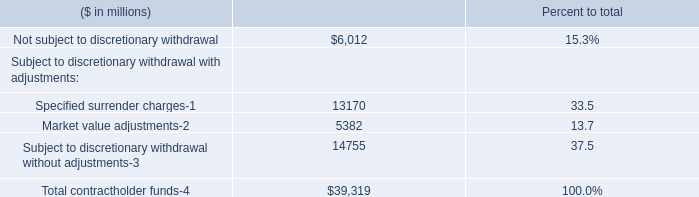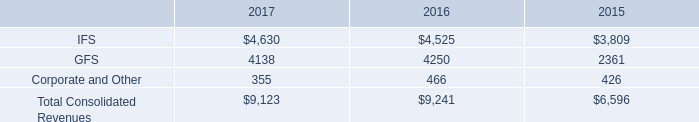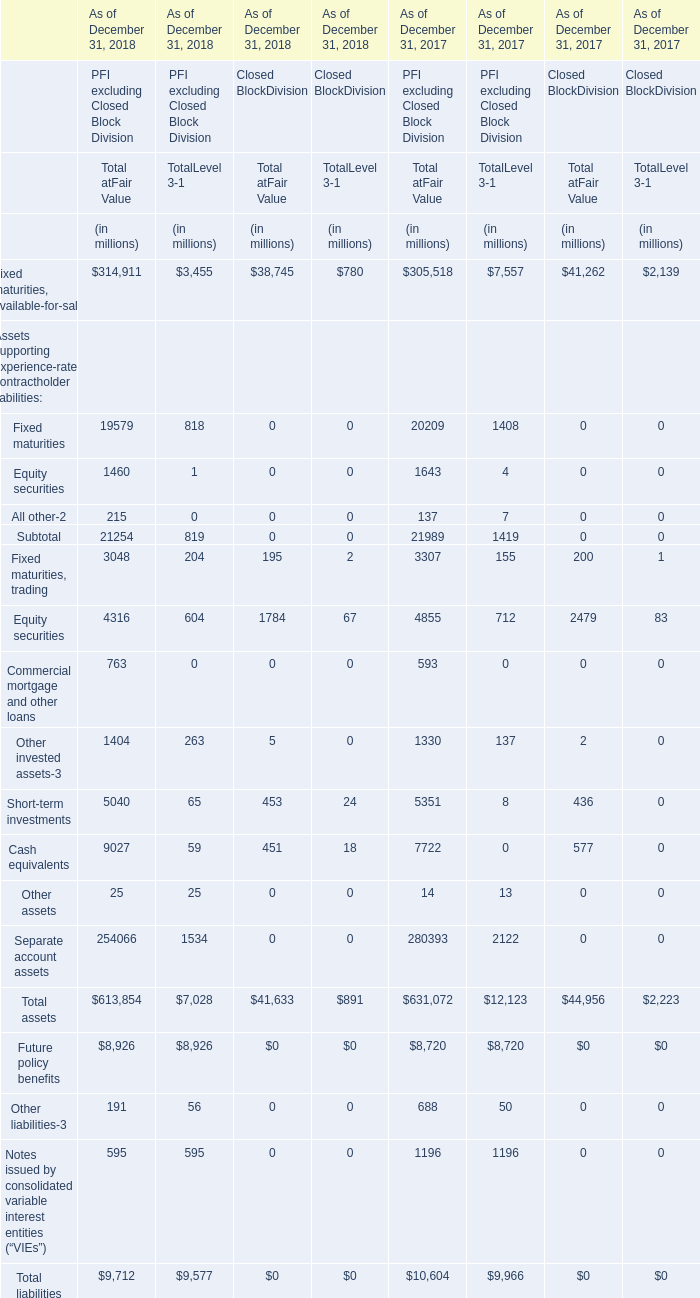what is the growth rate in revenues generated by the fis segment from 2016 to 2017? 
Computations: ((4630 - 4525) / 4525)
Answer: 0.0232. 